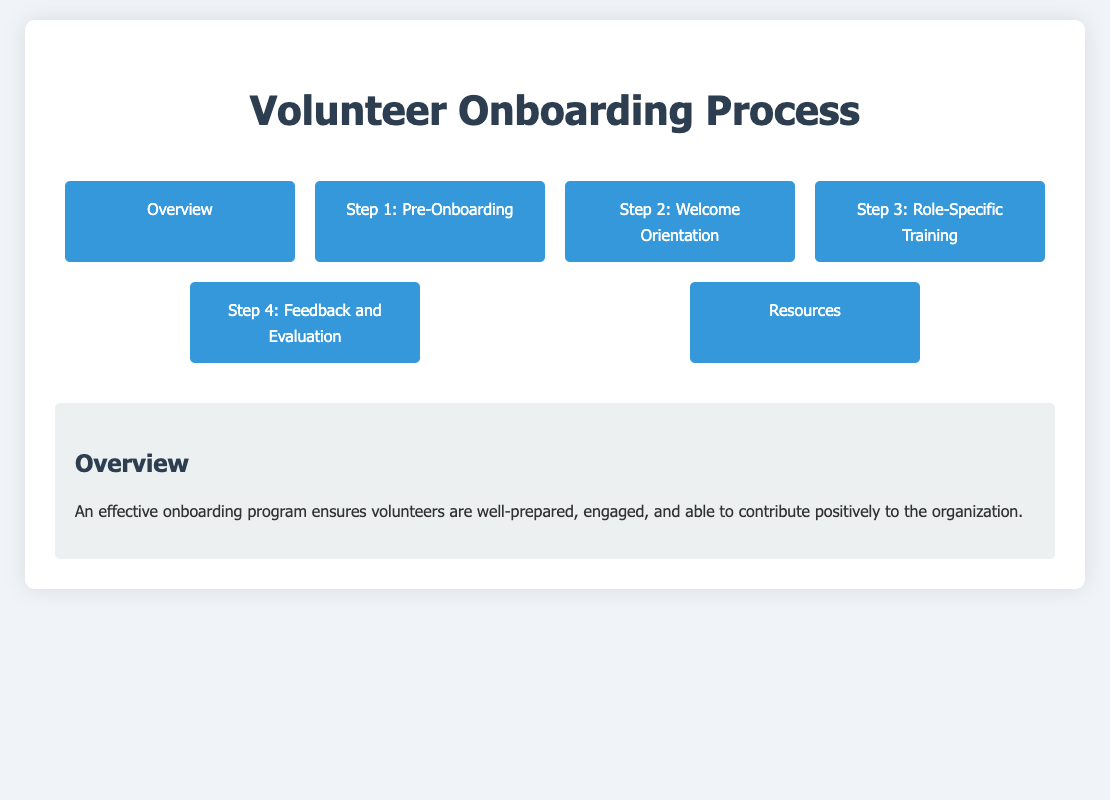What is the title of the document? The title of the document is presented at the top of the page as the main heading.
Answer: Volunteer Onboarding Process What is included in Step 1 of the onboarding process? Step 1 outlines the actions needed to prepare for new volunteers before they start.
Answer: Pre-Onboarding Preparation How many main steps are outlined in the onboarding process? The onboarding process divides the preparation into distinct stages, which can be counted from the menu.
Answer: Four What materials are listed for Welcome Orientation? This refers to the specific training materials mentioned for new volunteers during their orientation.
Answer: Orientation presentation slides What type of feedback is collected in Step 4? This determines the nature of feedback that focuses on assessing the onboarding experience for volunteers.
Answer: Onboarding feedback survey What is one resource mentioned for further reading? The document provides a list of literature that volunteers can read to enhance their knowledge.
Answer: Volunteer Management: Mobilizing All the Resources of the Community What is the purpose of the checklist in Step 1? Understanding the specific use of the checklist helps in outlining the preparatory steps for onboarding.
Answer: Prepare essential materials What is a role-specific training method mentioned in Step 3? This refers to training formats tailored to the unique responsibilities of volunteers in their roles.
Answer: Shadowing opportunities What document type-specific item is mentioned in the Resources section? This indicates a unique template provided for maintaining consistent communication with volunteers.
Answer: Welcome letter template 